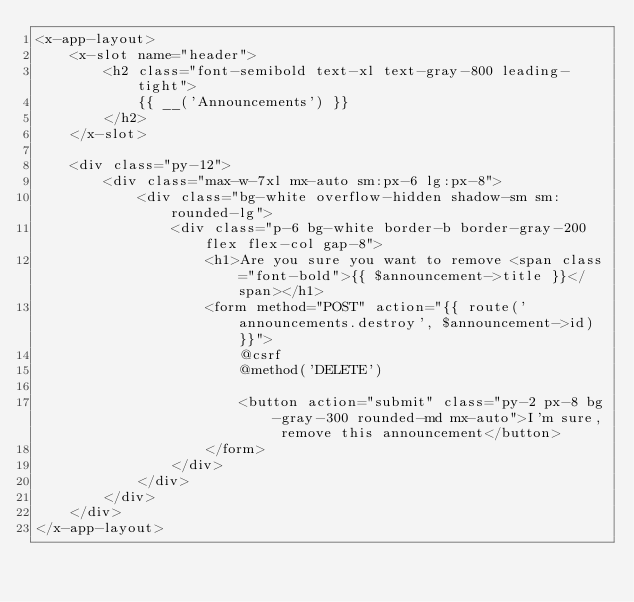Convert code to text. <code><loc_0><loc_0><loc_500><loc_500><_PHP_><x-app-layout>
    <x-slot name="header">
        <h2 class="font-semibold text-xl text-gray-800 leading-tight">
            {{ __('Announcements') }}
        </h2>
    </x-slot>

    <div class="py-12">
        <div class="max-w-7xl mx-auto sm:px-6 lg:px-8">
            <div class="bg-white overflow-hidden shadow-sm sm:rounded-lg">
                <div class="p-6 bg-white border-b border-gray-200 flex flex-col gap-8">
                    <h1>Are you sure you want to remove <span class="font-bold">{{ $announcement->title }}</span></h1>
                    <form method="POST" action="{{ route('announcements.destroy', $announcement->id) }}">
                        @csrf
                        @method('DELETE')

                        <button action="submit" class="py-2 px-8 bg-gray-300 rounded-md mx-auto">I'm sure, remove this announcement</button>
                    </form>
                </div>
            </div>
        </div>
    </div>
</x-app-layout>
</code> 